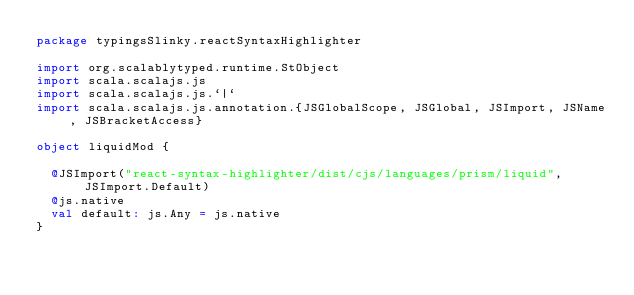Convert code to text. <code><loc_0><loc_0><loc_500><loc_500><_Scala_>package typingsSlinky.reactSyntaxHighlighter

import org.scalablytyped.runtime.StObject
import scala.scalajs.js
import scala.scalajs.js.`|`
import scala.scalajs.js.annotation.{JSGlobalScope, JSGlobal, JSImport, JSName, JSBracketAccess}

object liquidMod {
  
  @JSImport("react-syntax-highlighter/dist/cjs/languages/prism/liquid", JSImport.Default)
  @js.native
  val default: js.Any = js.native
}
</code> 